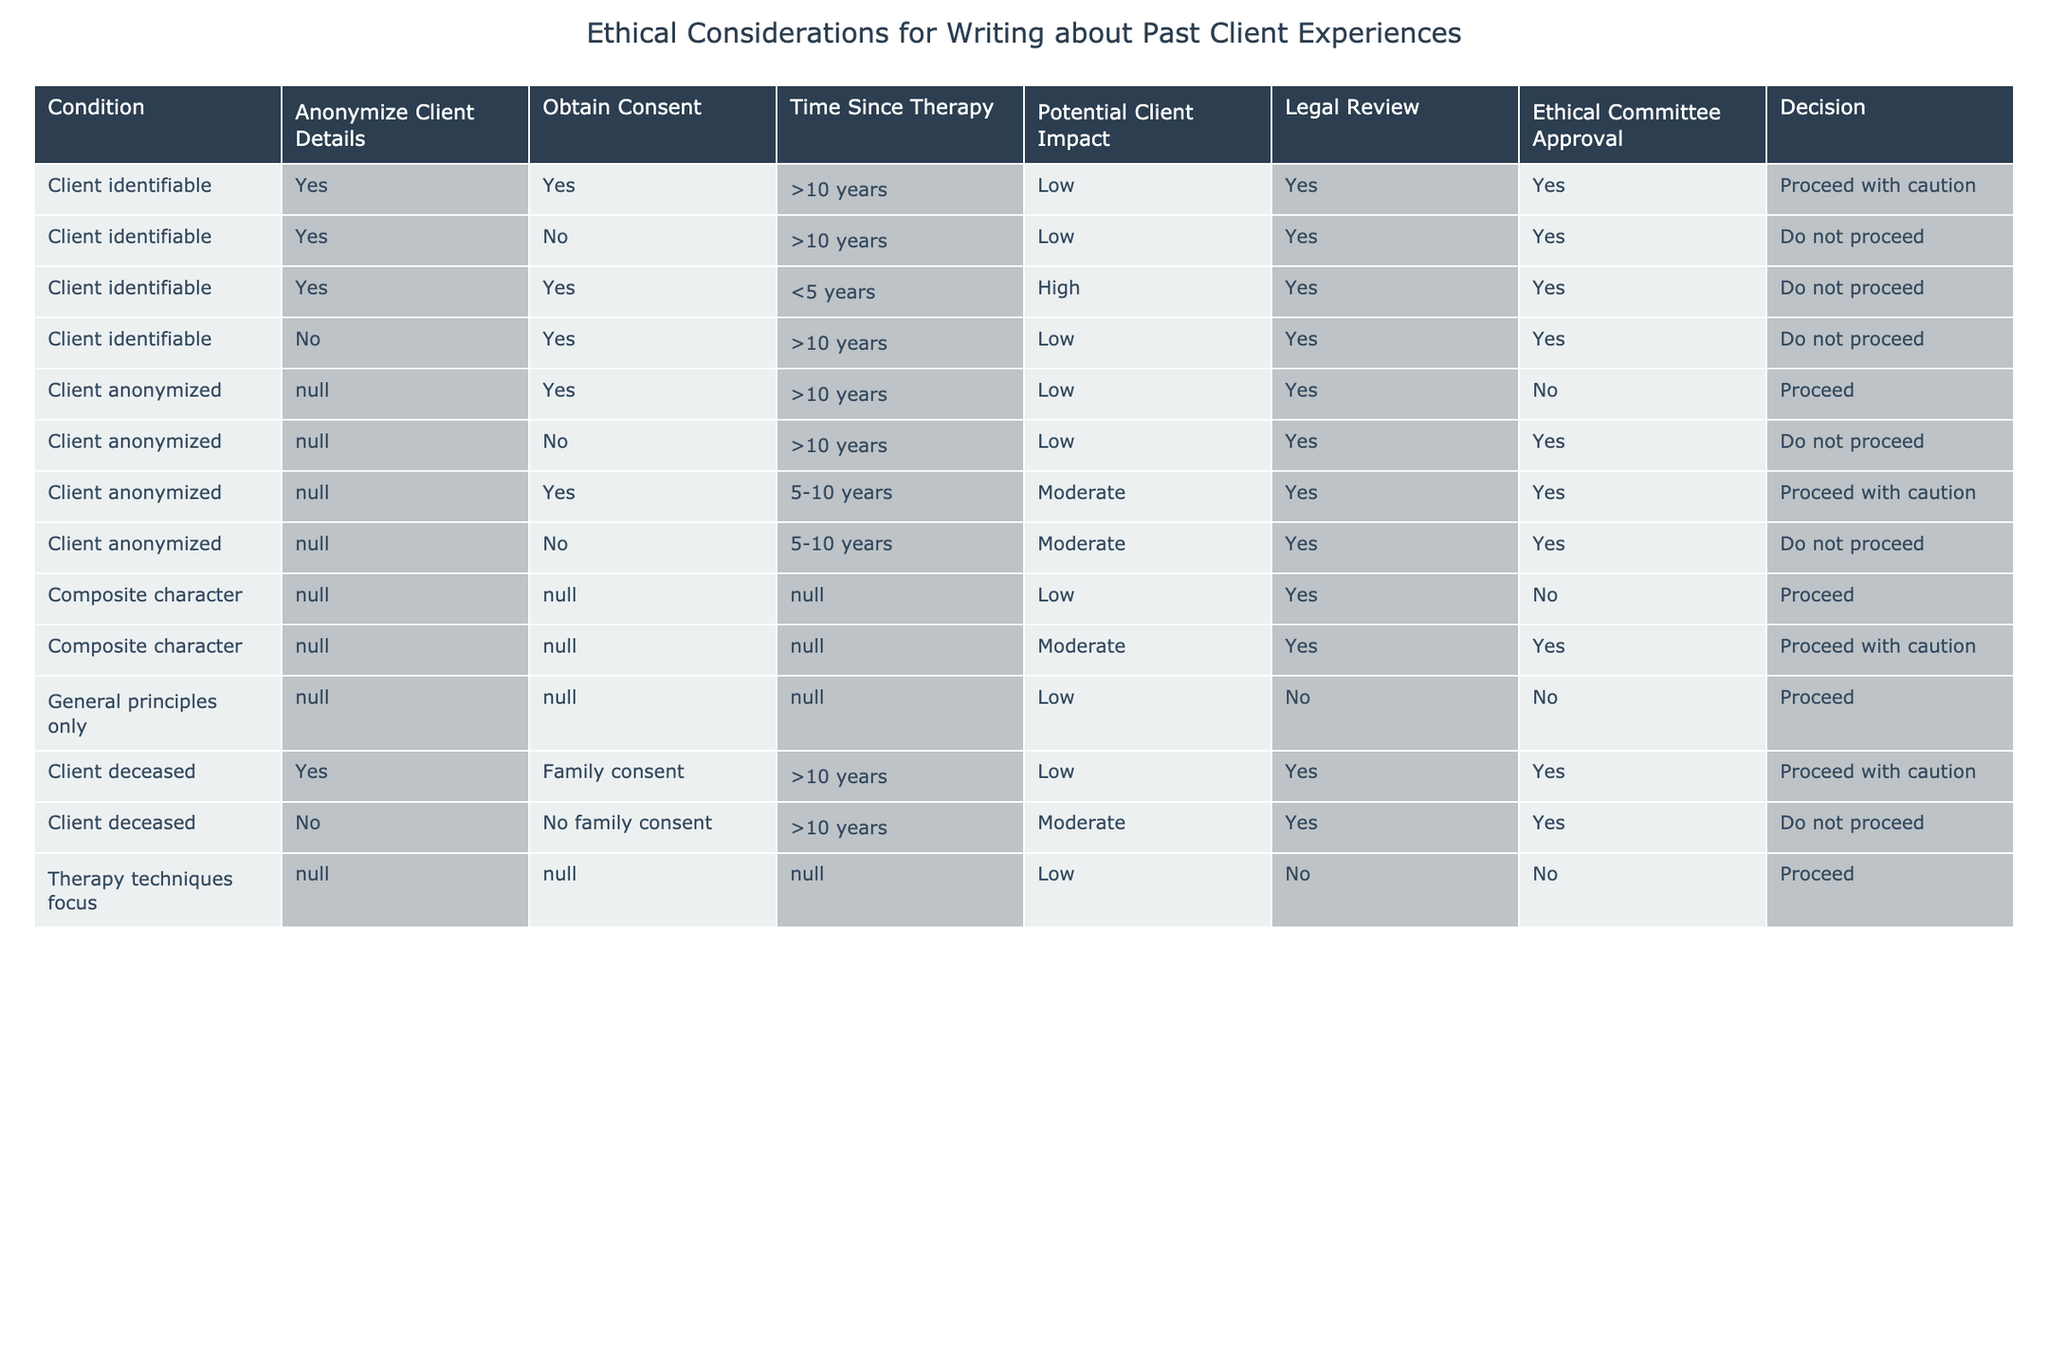What is the decision for a client identifiable with no consent after more than 10 years? According to the table, the decision for a client identifiable, who has not obtained consent and has been more than 10 years since therapy, is "Do not proceed". This is directly stated in the row corresponding to those conditions.
Answer: Do not proceed Does obtaining consent matter if the client's details are anonymized? Yes, if the client's details are anonymized and consent is not obtained, the decision is "Do not proceed". This is indicated in the rows for anonymized clients across different timelines where consent is necessary.
Answer: Yes What is the potential client impact for client identifiable cases with consent and over 10 years since therapy? For client identifiable cases with consent and more than 10 years since therapy, the potential client impact is categorized as "Low". This value is derived from the respective row in the table with those specific conditions.
Answer: Low How many total cases allow proceeding with caution based on the table? There are three cases where the decision is "Proceed with caution": 1) Client identifiable with consent and over 10 years since therapy, 2) Client anonymized with consent and 5-10 years since therapy, and 3) Client deceased with family consent and over 10 years since therapy. This requires adding them based on the decision column.
Answer: 3 If a client is deceased, what factors most influence the decision to proceed? For deceased clients, the key factors influencing the decision to proceed are obtaining family consent and the time since therapy. Specifically, if family consent is obtained and therapy occurred more than 10 years ago, the decision is to proceed with caution. If there is no family consent, the decision is to not proceed. Thus, both factors are crucial.
Answer: Family consent and time since therapy What is the decision when using composite character experiences? The table shows that regardless of the specifics (N/A), if the character is composite, the decision is "Proceed" if the potential impact is low and "Proceed with caution" if the impact is moderate. This is clearly defined in the rows pertaining to composite characters.
Answer: Proceed and Proceed with caution Is it acceptable to write about clients using only general principles? Yes, referring to the table, writing based solely on general principles is indicated as a valid option with a decision to "Proceed". There are no specific constraints for this category, making it acceptable.
Answer: Yes What happens if a client is anonymized after less than 5 years since therapy? In this case, if a client is anonymized and therapy occurred less than 5 years ago, the potential client impact is "High", resulting in a decision of "Do not proceed". This is directly stated in the relevant row of the table.
Answer: Do not proceed 